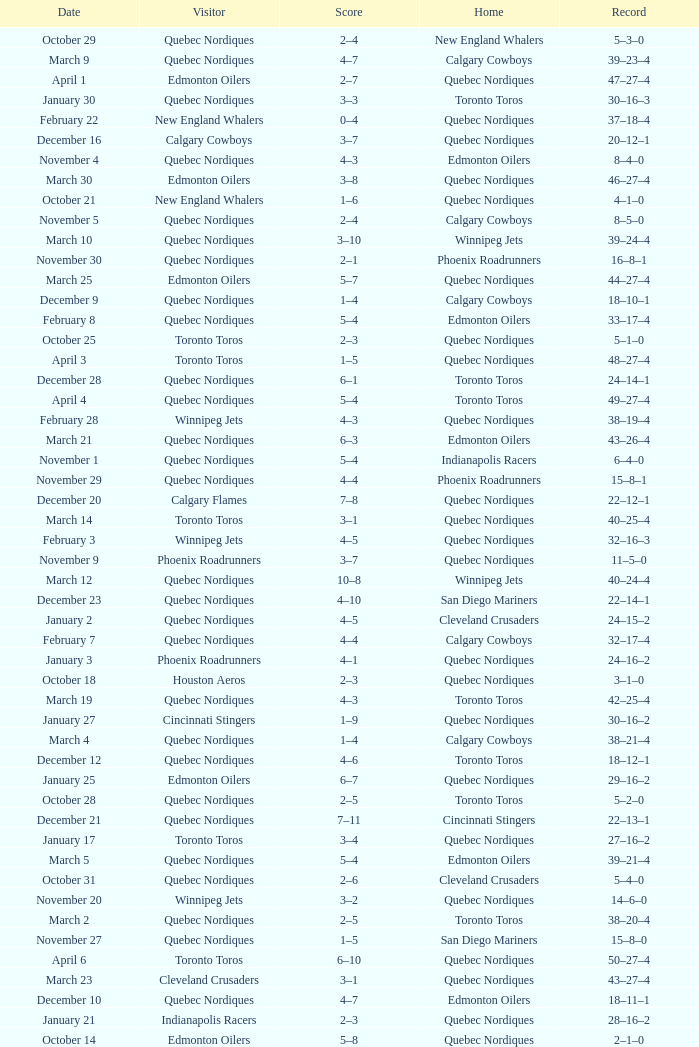What was the date of the game with a score of 2–1? November 30. 